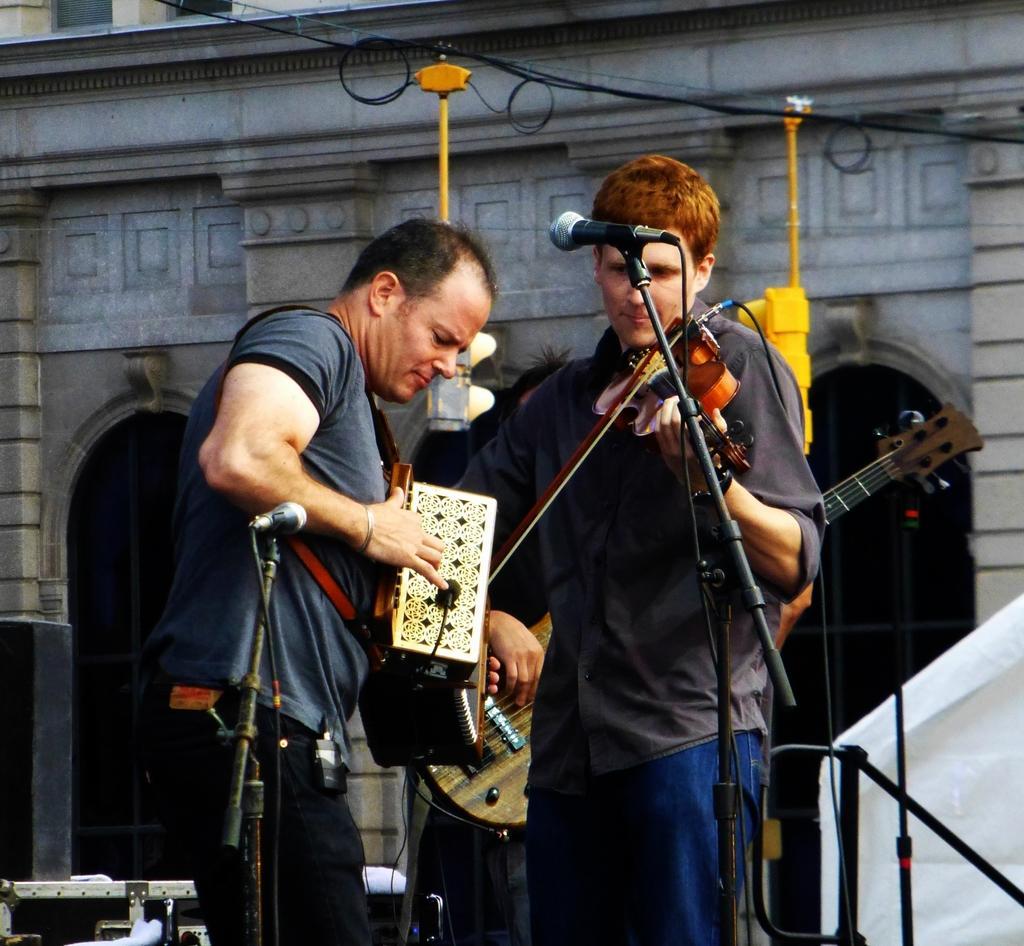In one or two sentences, can you explain what this image depicts? 2 people are standing. a person at the right is playing violin and the person at the left is playing harmonium. in front of them there are microphones and behind them there is a building. 